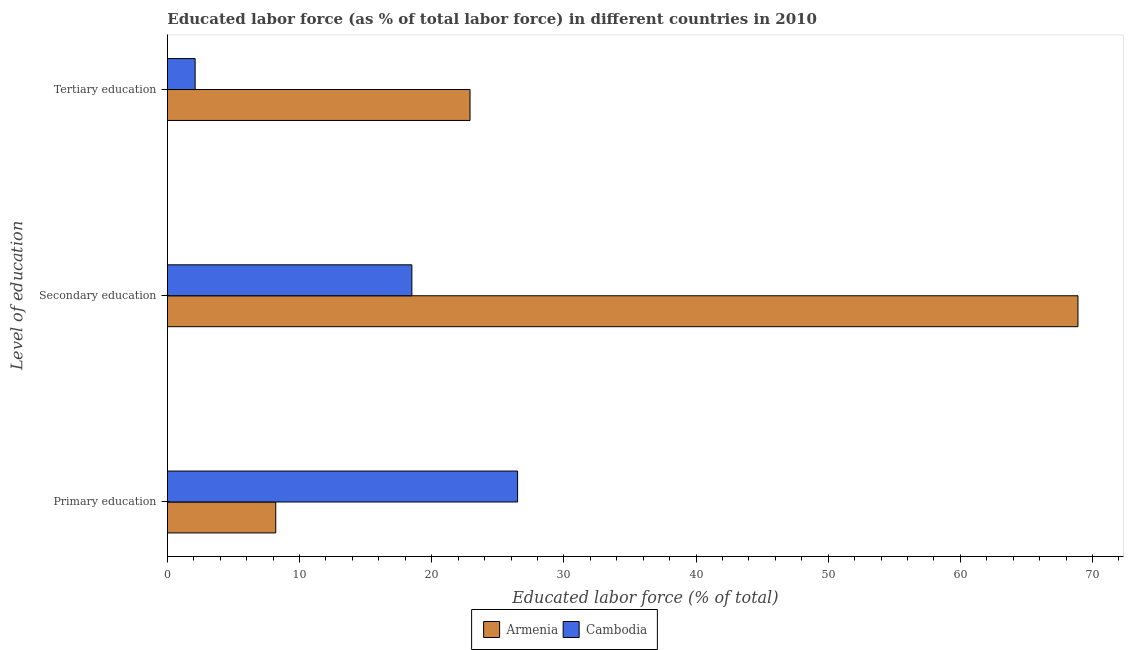How many different coloured bars are there?
Make the answer very short. 2. How many bars are there on the 1st tick from the bottom?
Provide a succinct answer. 2. What is the label of the 2nd group of bars from the top?
Offer a very short reply. Secondary education. What is the percentage of labor force who received tertiary education in Armenia?
Give a very brief answer. 22.9. Across all countries, what is the maximum percentage of labor force who received primary education?
Give a very brief answer. 26.5. Across all countries, what is the minimum percentage of labor force who received secondary education?
Give a very brief answer. 18.5. In which country was the percentage of labor force who received tertiary education maximum?
Give a very brief answer. Armenia. In which country was the percentage of labor force who received secondary education minimum?
Your answer should be compact. Cambodia. What is the total percentage of labor force who received tertiary education in the graph?
Offer a very short reply. 25. What is the difference between the percentage of labor force who received tertiary education in Armenia and that in Cambodia?
Make the answer very short. 20.8. What is the difference between the percentage of labor force who received primary education in Cambodia and the percentage of labor force who received tertiary education in Armenia?
Provide a short and direct response. 3.6. What is the average percentage of labor force who received tertiary education per country?
Provide a succinct answer. 12.5. What is the difference between the percentage of labor force who received primary education and percentage of labor force who received secondary education in Armenia?
Your answer should be very brief. -60.7. In how many countries, is the percentage of labor force who received primary education greater than 2 %?
Make the answer very short. 2. What is the ratio of the percentage of labor force who received primary education in Cambodia to that in Armenia?
Give a very brief answer. 3.23. Is the percentage of labor force who received secondary education in Cambodia less than that in Armenia?
Make the answer very short. Yes. What is the difference between the highest and the second highest percentage of labor force who received tertiary education?
Keep it short and to the point. 20.8. What is the difference between the highest and the lowest percentage of labor force who received secondary education?
Make the answer very short. 50.4. In how many countries, is the percentage of labor force who received tertiary education greater than the average percentage of labor force who received tertiary education taken over all countries?
Give a very brief answer. 1. Is the sum of the percentage of labor force who received primary education in Cambodia and Armenia greater than the maximum percentage of labor force who received secondary education across all countries?
Ensure brevity in your answer.  No. What does the 1st bar from the top in Tertiary education represents?
Your answer should be very brief. Cambodia. What does the 1st bar from the bottom in Primary education represents?
Your response must be concise. Armenia. Is it the case that in every country, the sum of the percentage of labor force who received primary education and percentage of labor force who received secondary education is greater than the percentage of labor force who received tertiary education?
Your answer should be very brief. Yes. How many bars are there?
Ensure brevity in your answer.  6. Are all the bars in the graph horizontal?
Ensure brevity in your answer.  Yes. What is the difference between two consecutive major ticks on the X-axis?
Provide a short and direct response. 10. Are the values on the major ticks of X-axis written in scientific E-notation?
Ensure brevity in your answer.  No. Does the graph contain any zero values?
Give a very brief answer. No. Where does the legend appear in the graph?
Your response must be concise. Bottom center. What is the title of the graph?
Give a very brief answer. Educated labor force (as % of total labor force) in different countries in 2010. What is the label or title of the X-axis?
Your answer should be compact. Educated labor force (% of total). What is the label or title of the Y-axis?
Give a very brief answer. Level of education. What is the Educated labor force (% of total) in Armenia in Primary education?
Keep it short and to the point. 8.2. What is the Educated labor force (% of total) in Armenia in Secondary education?
Ensure brevity in your answer.  68.9. What is the Educated labor force (% of total) in Cambodia in Secondary education?
Your answer should be very brief. 18.5. What is the Educated labor force (% of total) of Armenia in Tertiary education?
Offer a very short reply. 22.9. What is the Educated labor force (% of total) in Cambodia in Tertiary education?
Offer a very short reply. 2.1. Across all Level of education, what is the maximum Educated labor force (% of total) in Armenia?
Make the answer very short. 68.9. Across all Level of education, what is the minimum Educated labor force (% of total) of Armenia?
Your answer should be very brief. 8.2. Across all Level of education, what is the minimum Educated labor force (% of total) in Cambodia?
Ensure brevity in your answer.  2.1. What is the total Educated labor force (% of total) of Armenia in the graph?
Your answer should be very brief. 100. What is the total Educated labor force (% of total) of Cambodia in the graph?
Your answer should be compact. 47.1. What is the difference between the Educated labor force (% of total) of Armenia in Primary education and that in Secondary education?
Your response must be concise. -60.7. What is the difference between the Educated labor force (% of total) of Cambodia in Primary education and that in Secondary education?
Provide a succinct answer. 8. What is the difference between the Educated labor force (% of total) in Armenia in Primary education and that in Tertiary education?
Your response must be concise. -14.7. What is the difference between the Educated labor force (% of total) of Cambodia in Primary education and that in Tertiary education?
Ensure brevity in your answer.  24.4. What is the difference between the Educated labor force (% of total) in Armenia in Secondary education and that in Tertiary education?
Keep it short and to the point. 46. What is the difference between the Educated labor force (% of total) of Cambodia in Secondary education and that in Tertiary education?
Offer a terse response. 16.4. What is the difference between the Educated labor force (% of total) in Armenia in Primary education and the Educated labor force (% of total) in Cambodia in Secondary education?
Your answer should be compact. -10.3. What is the difference between the Educated labor force (% of total) of Armenia in Secondary education and the Educated labor force (% of total) of Cambodia in Tertiary education?
Your response must be concise. 66.8. What is the average Educated labor force (% of total) of Armenia per Level of education?
Your answer should be very brief. 33.33. What is the difference between the Educated labor force (% of total) of Armenia and Educated labor force (% of total) of Cambodia in Primary education?
Your response must be concise. -18.3. What is the difference between the Educated labor force (% of total) in Armenia and Educated labor force (% of total) in Cambodia in Secondary education?
Give a very brief answer. 50.4. What is the difference between the Educated labor force (% of total) in Armenia and Educated labor force (% of total) in Cambodia in Tertiary education?
Your response must be concise. 20.8. What is the ratio of the Educated labor force (% of total) in Armenia in Primary education to that in Secondary education?
Offer a very short reply. 0.12. What is the ratio of the Educated labor force (% of total) in Cambodia in Primary education to that in Secondary education?
Make the answer very short. 1.43. What is the ratio of the Educated labor force (% of total) of Armenia in Primary education to that in Tertiary education?
Provide a succinct answer. 0.36. What is the ratio of the Educated labor force (% of total) in Cambodia in Primary education to that in Tertiary education?
Your answer should be very brief. 12.62. What is the ratio of the Educated labor force (% of total) in Armenia in Secondary education to that in Tertiary education?
Keep it short and to the point. 3.01. What is the ratio of the Educated labor force (% of total) in Cambodia in Secondary education to that in Tertiary education?
Your answer should be compact. 8.81. What is the difference between the highest and the second highest Educated labor force (% of total) in Armenia?
Provide a short and direct response. 46. What is the difference between the highest and the lowest Educated labor force (% of total) in Armenia?
Keep it short and to the point. 60.7. What is the difference between the highest and the lowest Educated labor force (% of total) of Cambodia?
Keep it short and to the point. 24.4. 